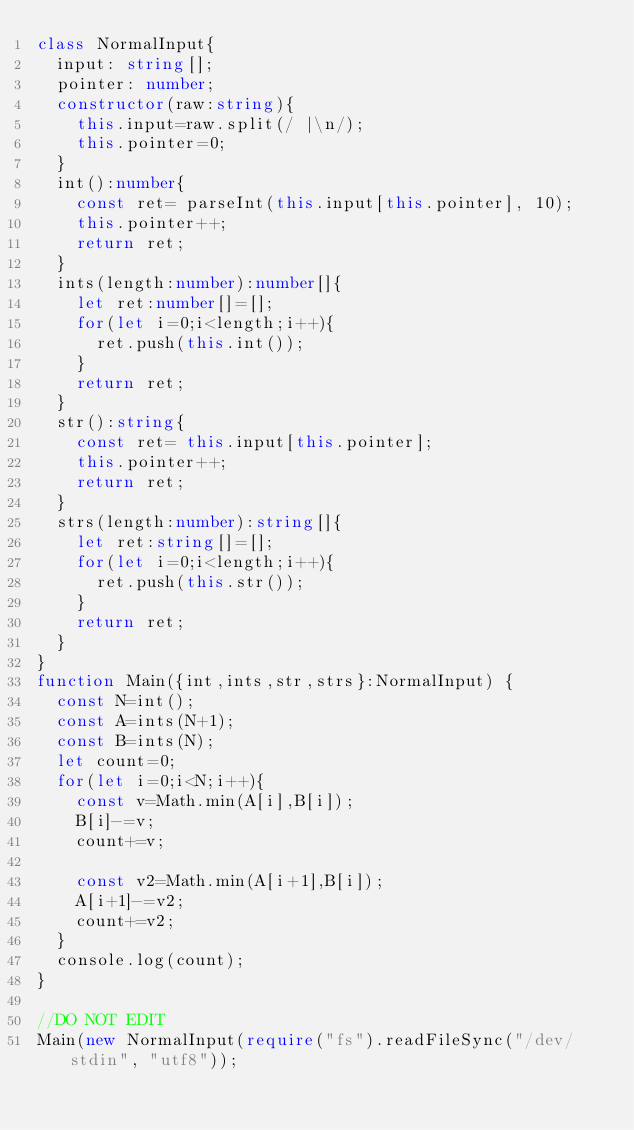Convert code to text. <code><loc_0><loc_0><loc_500><loc_500><_TypeScript_>class NormalInput{
  input: string[];
  pointer: number;
  constructor(raw:string){
    this.input=raw.split(/ |\n/);
    this.pointer=0;
  }
  int():number{
    const ret= parseInt(this.input[this.pointer], 10);
    this.pointer++;
    return ret;
  }  
  ints(length:number):number[]{
    let ret:number[]=[];
    for(let i=0;i<length;i++){
      ret.push(this.int());
    }
    return ret;
  }
  str():string{
    const ret= this.input[this.pointer];
    this.pointer++;
    return ret;
  }
  strs(length:number):string[]{
    let ret:string[]=[];
    for(let i=0;i<length;i++){
      ret.push(this.str());
    }
    return ret;
  }
}
function Main({int,ints,str,strs}:NormalInput) {
  const N=int();
  const A=ints(N+1);
  const B=ints(N);
  let count=0;
  for(let i=0;i<N;i++){
    const v=Math.min(A[i],B[i]);
    B[i]-=v;
    count+=v;

    const v2=Math.min(A[i+1],B[i]);
    A[i+1]-=v2;
    count+=v2;
  }
  console.log(count);
}

//DO NOT EDIT
Main(new NormalInput(require("fs").readFileSync("/dev/stdin", "utf8"));
</code> 